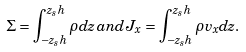Convert formula to latex. <formula><loc_0><loc_0><loc_500><loc_500>\Sigma = \int _ { - z _ { s } h } ^ { z _ { s } h } \rho d z \, a n d \, J _ { x } = \int _ { - z _ { s } h } ^ { z _ { s } h } \rho v _ { x } d z .</formula> 